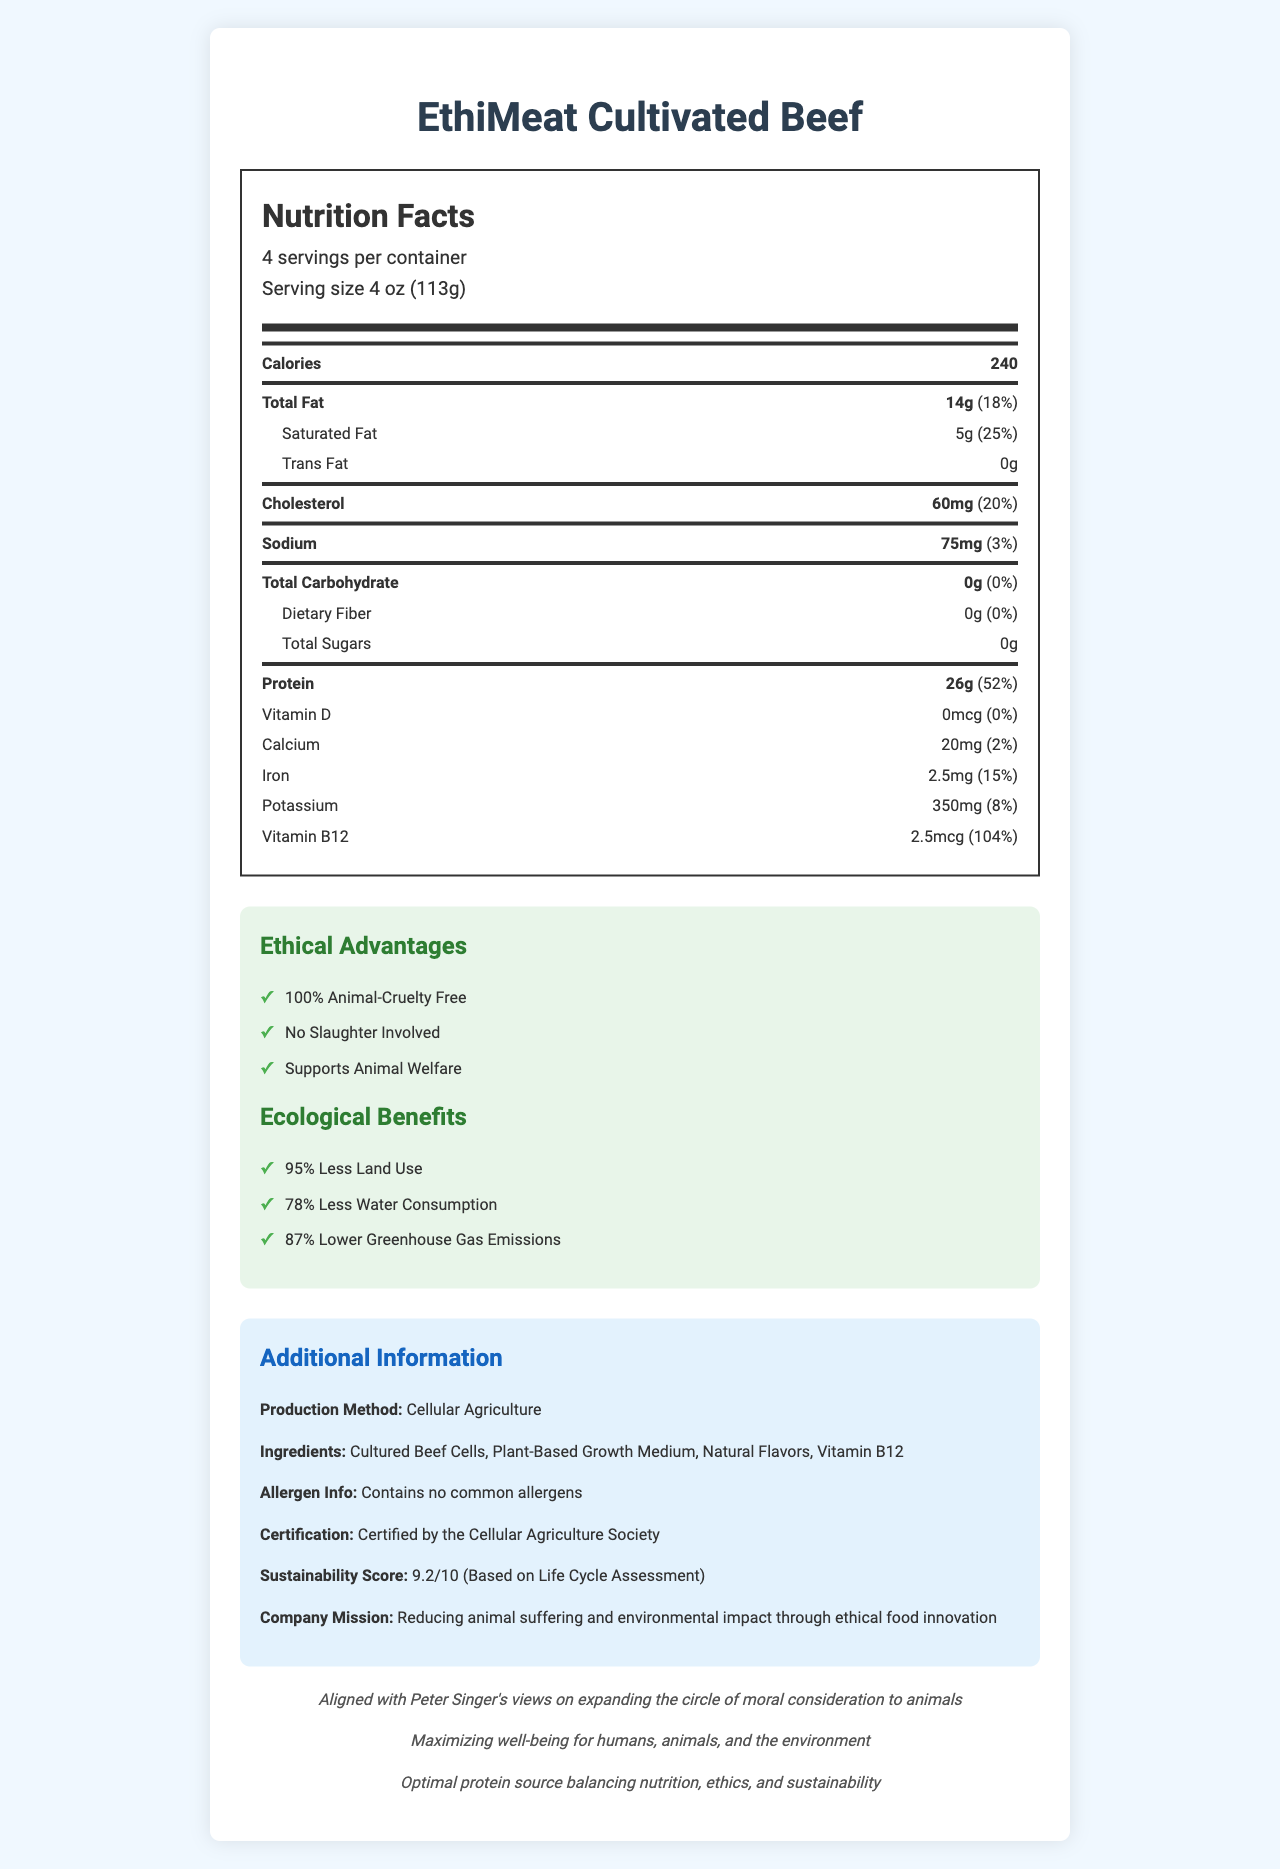what is the serving size for EthiMeat Cultivated Beef? The serving size is listed as 4 oz (113g) within the nutrition facts section of the document.
Answer: 4 oz (113g) how many servings are there per container? The document states that there are 4 servings per container.
Answer: 4 how many calories are in one serving of EthiMeat Cultivated Beef? The number of calories per serving is displayed as 240 in the nutrition facts section.
Answer: 240 what is the total fat content per serving? The total fat content per serving is listed as 14g.
Answer: 14g what certification does EthiMeat Cultivated Beef have? The document mentions that the product is "Certified by the Cellular Agriculture Society."
Answer: Certified by the Cellular Agriculture Society how much protein does EthiMeat Cultivated Beef contain per serving? The protein content per serving is 26g as mentioned in the nutrition facts.
Answer: 26g how much is the daily value percentage of iron per serving? The iron daily value percentage per serving is listed as 15%.
Answer: 15% how many milligrams of sodium are in each serving? The sodium content per serving is 75mg as indicated in the nutrition facts.
Answer: 75mg which of the following is NOT an ethical advantage of EthiMeat Cultivated Beef? A. 100% Animal-Cruelty Free B. No Slaughter Involved C. Supports Animal Welfare D. Reduces Cholesterol Levels The listed ethical advantages are "100% Animal-Cruelty Free," "No Slaughter Involved," and "Supports Animal Welfare." Reducing cholesterol levels is not mentioned as an ethical advantage.
Answer: D based on the document, which one of the following ecological benefits is NOT associated with EthiMeat Cultivated Beef? Ⅰ. 95% Less Land Use Ⅱ. 78% Less Water Consumption Ⅲ. 75% Lower Greenhouse Gas Emissions Ⅳ. 87% Lower Greenhouse Gas Emissions The document states "95% Less Land Use," "78% Less Water Consumption," and "87% Lower Greenhouse Gas Emissions" as the ecological benefits. Therefore, "75% Lower Greenhouse Gas Emissions" is not listed.
Answer: III. 75% Lower Greenhouse Gas Emissions is EthiMeat Cultivated Beef allergen-free? The document specifies that the product "contains no common allergens."
Answer: Yes describe the main idea of the document. This document emphasizes the nutritional, ethical, and ecological benefits of the lab-grown meat product, EthiMeat Cultivated Beef. It provides a detailed breakdown of its nutritional facts, outlines significant ethical practices like being cruelty-free, and lists ecological benefits such as less land and water use and lower greenhouse gas emissions. The production method, ingredients, allergen information, certification, and sustainability score are also mentioned to provide a comprehensive overview of the product.
Answer: EthiMeat Cultivated Beef is a lab-grown meat product presented as a nutritious and ethical alternative to conventional meat. The document highlights its nutritional benefits, such as high protein content and essential vitamins, as well as ethical and ecological advantages like cruelty-free production and reduced environmental impact. is information about the cost of EthiMeat Cultivated Beef provided in the document? The document does not provide any details about the cost or pricing of EthiMeat Cultivated Beef.
Answer: Not enough information 